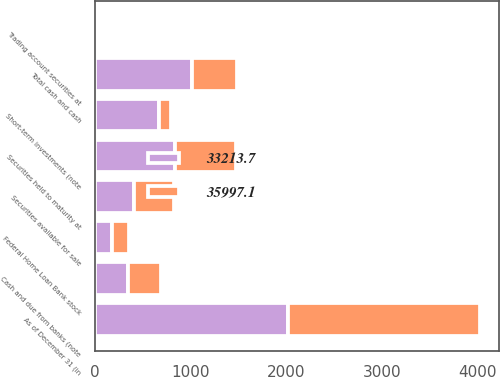<chart> <loc_0><loc_0><loc_500><loc_500><stacked_bar_chart><ecel><fcel>As of December 31 (in<fcel>Cash and due from banks (note<fcel>Short-term investments (note<fcel>Total cash and cash<fcel>Trading account securities at<fcel>Securities available for sale<fcel>Securities held to maturity at<fcel>Federal Home Loan Bank stock<nl><fcel>33213.7<fcel>2014<fcel>345.1<fcel>668.6<fcel>1013.7<fcel>8.3<fcel>412.6<fcel>834.3<fcel>175.7<nl><fcel>35997.1<fcel>2013<fcel>350.8<fcel>123.6<fcel>474.4<fcel>8.3<fcel>412.6<fcel>640.5<fcel>175.7<nl></chart> 